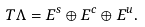<formula> <loc_0><loc_0><loc_500><loc_500>T \Lambda = E ^ { s } \oplus E ^ { c } \oplus E ^ { u } .</formula> 